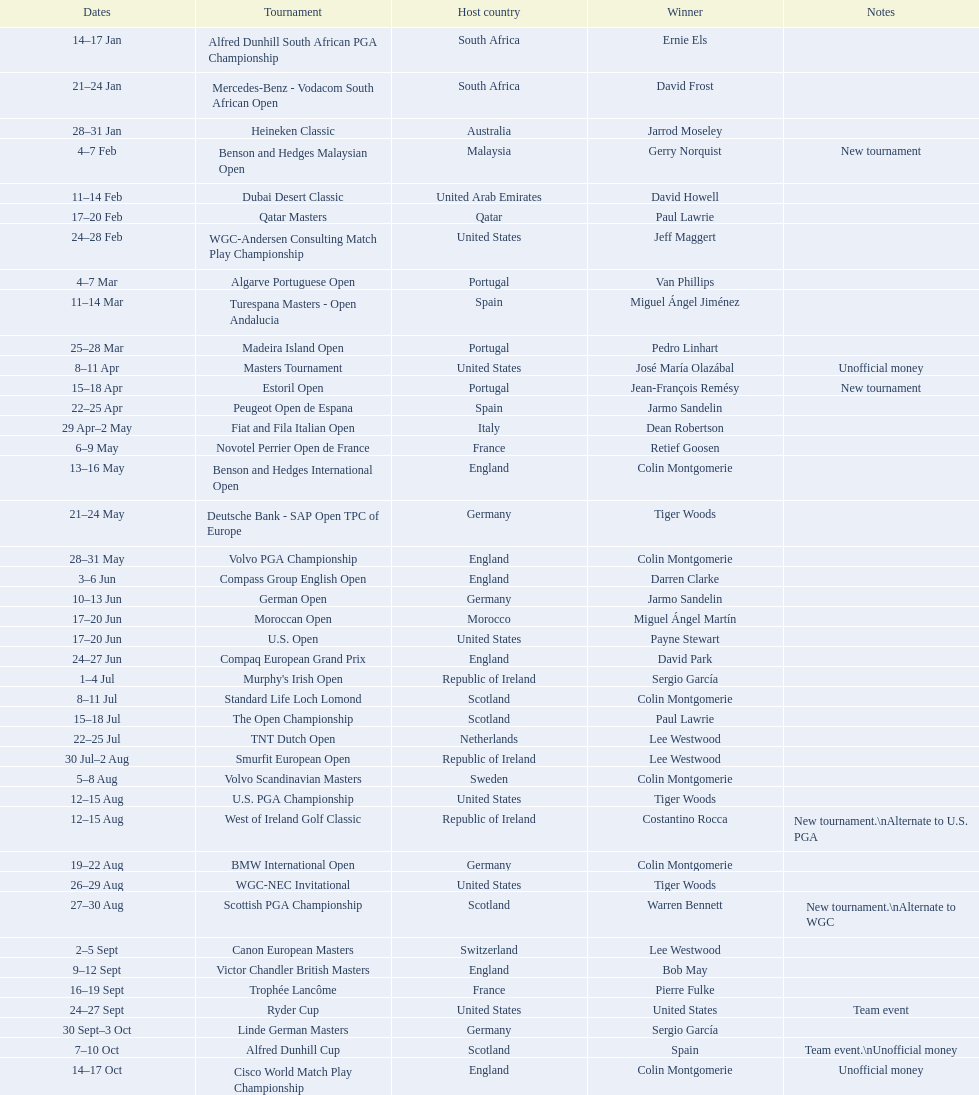Which winner won more tournaments, jeff maggert or tiger woods? Tiger Woods. 